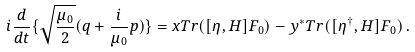<formula> <loc_0><loc_0><loc_500><loc_500>i \frac { d } { d t } \{ \sqrt { \frac { \mu _ { 0 } } { 2 } } ( q + \frac { i } { \mu _ { 0 } } p ) \} = x T r ( [ \eta , H ] F _ { 0 } ) - y ^ { * } T r ( [ \eta ^ { \dag } , H ] F _ { 0 } ) \, .</formula> 